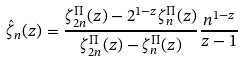<formula> <loc_0><loc_0><loc_500><loc_500>\hat { \zeta } _ { n } ( z ) = \frac { \zeta _ { 2 n } ^ { \Pi } ( z ) - 2 ^ { 1 - z } \zeta _ { n } ^ { \Pi } ( z ) } { \zeta _ { 2 n } ^ { \Pi } ( z ) - \zeta _ { n } ^ { \Pi } ( z ) } \frac { n ^ { 1 - z } } { z - 1 }</formula> 